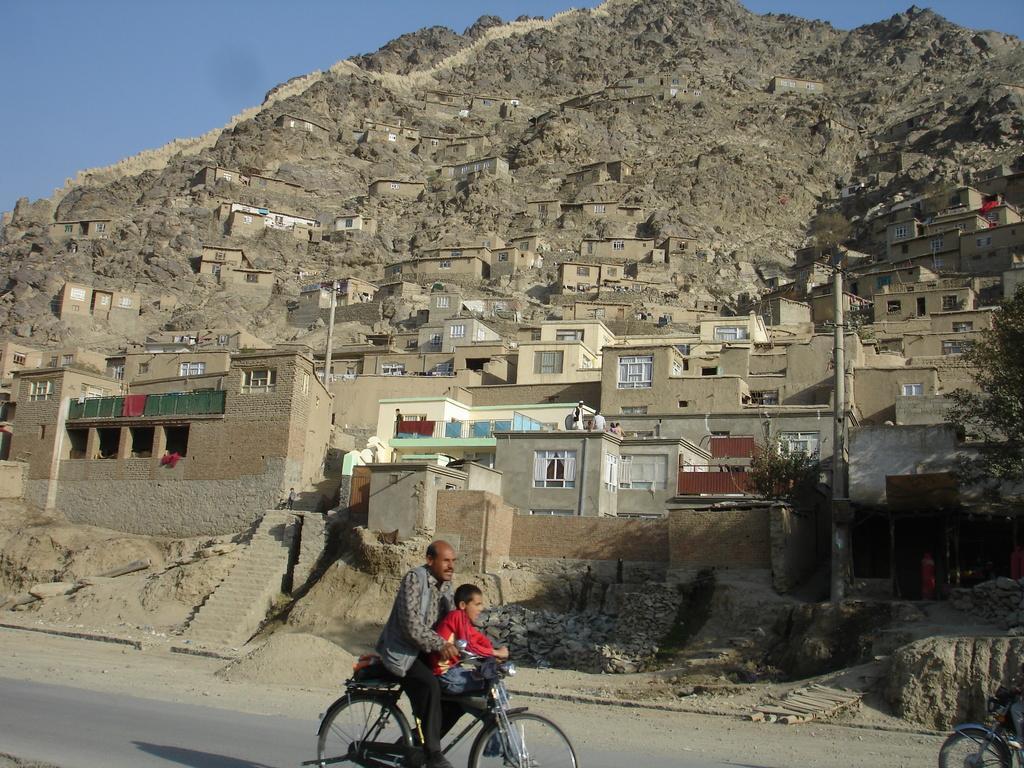Can you describe this image briefly? This might be a picture of a small town on hillside. In the foreground of the picture there is a road, on the road a man and a kid on bicycle are there. In the center of the picture there are many houses. On the top it is Hill. Sky is visible, it is clear and sunny. On the right there is a motor vehicle. 